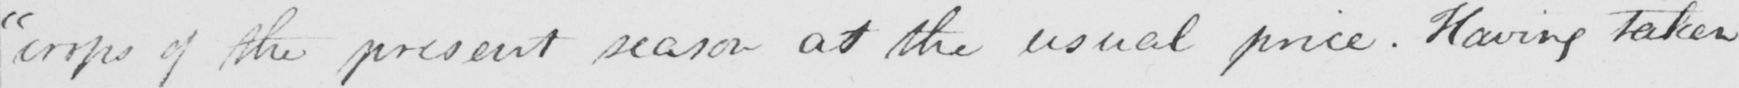Can you tell me what this handwritten text says? " crops of the present season at the usual price . Having taken 